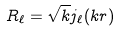<formula> <loc_0><loc_0><loc_500><loc_500>R _ { \ell } = \sqrt { k } j _ { \ell } ( k r )</formula> 